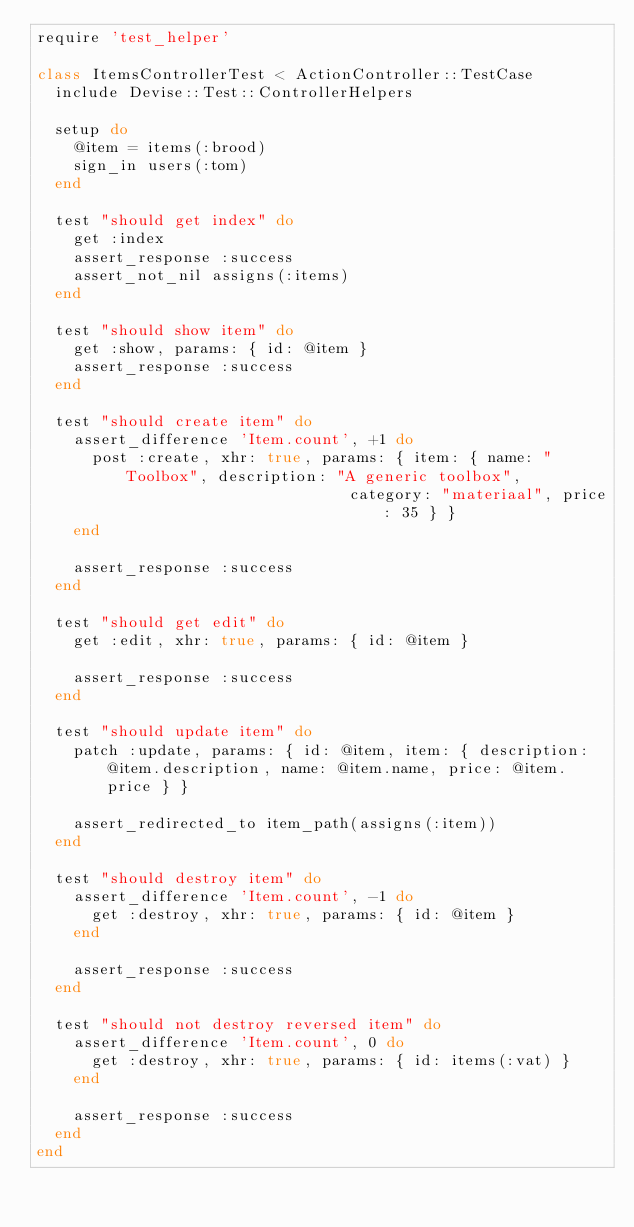<code> <loc_0><loc_0><loc_500><loc_500><_Ruby_>require 'test_helper'

class ItemsControllerTest < ActionController::TestCase
  include Devise::Test::ControllerHelpers

  setup do
    @item = items(:brood)
    sign_in users(:tom)
  end

  test "should get index" do
    get :index
    assert_response :success
    assert_not_nil assigns(:items)
  end

  test "should show item" do
    get :show, params: { id: @item }
    assert_response :success
  end

  test "should create item" do
    assert_difference 'Item.count', +1 do
      post :create, xhr: true, params: { item: { name: "Toolbox", description: "A generic toolbox",
                                  category: "materiaal", price: 35 } }
    end

    assert_response :success
  end

  test "should get edit" do
    get :edit, xhr: true, params: { id: @item }

    assert_response :success
  end

  test "should update item" do
    patch :update, params: { id: @item, item: { description: @item.description, name: @item.name, price: @item.price } }

    assert_redirected_to item_path(assigns(:item))
  end

  test "should destroy item" do
    assert_difference 'Item.count', -1 do
      get :destroy, xhr: true, params: { id: @item }
    end

    assert_response :success
  end

  test "should not destroy reversed item" do
    assert_difference 'Item.count', 0 do
      get :destroy, xhr: true, params: { id: items(:vat) }
    end

    assert_response :success
  end
end
</code> 